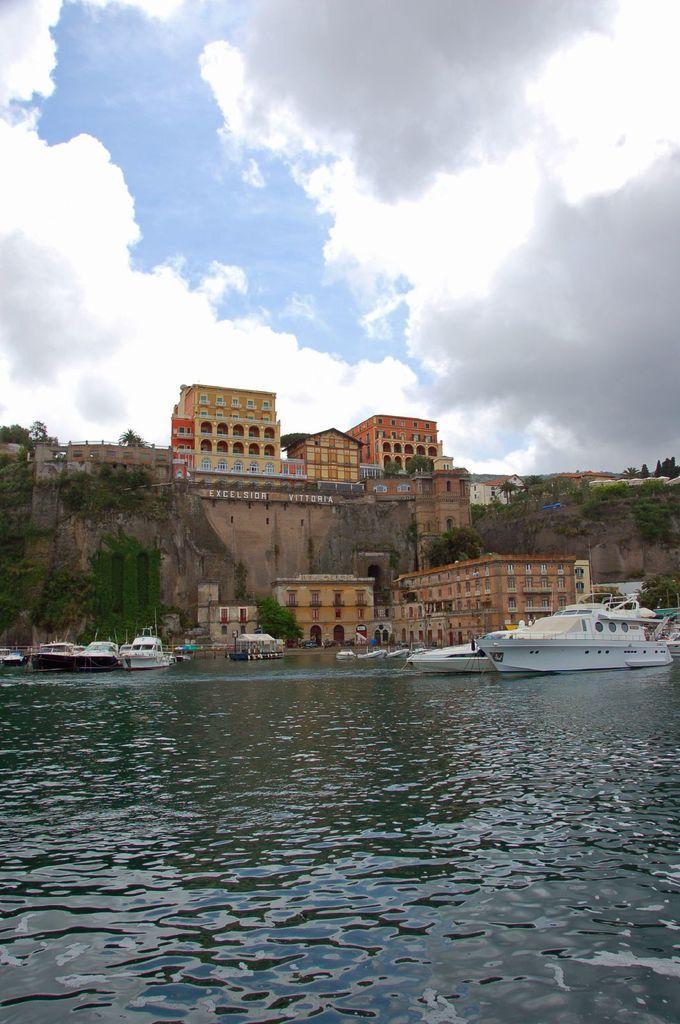In one or two sentences, can you explain what this image depicts? There are ships on the surface of water in the center of the image and there are buildings, wall, greenery and sky in the background area. 